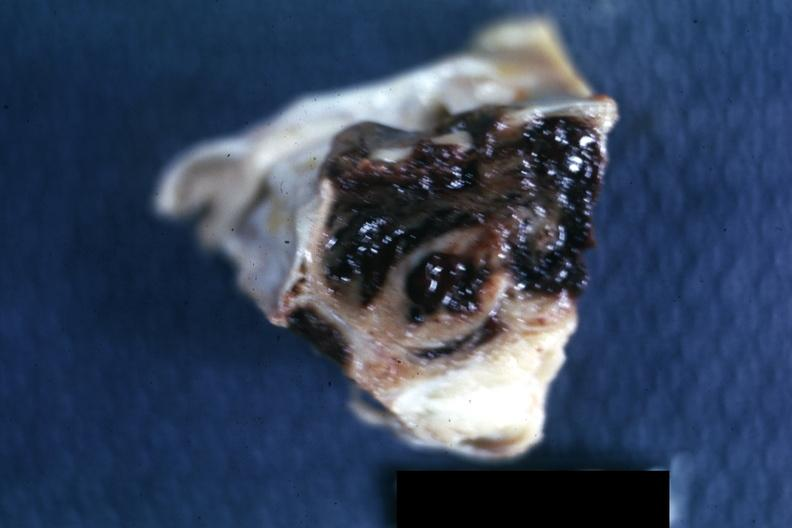does this image show excised sella?
Answer the question using a single word or phrase. Yes 